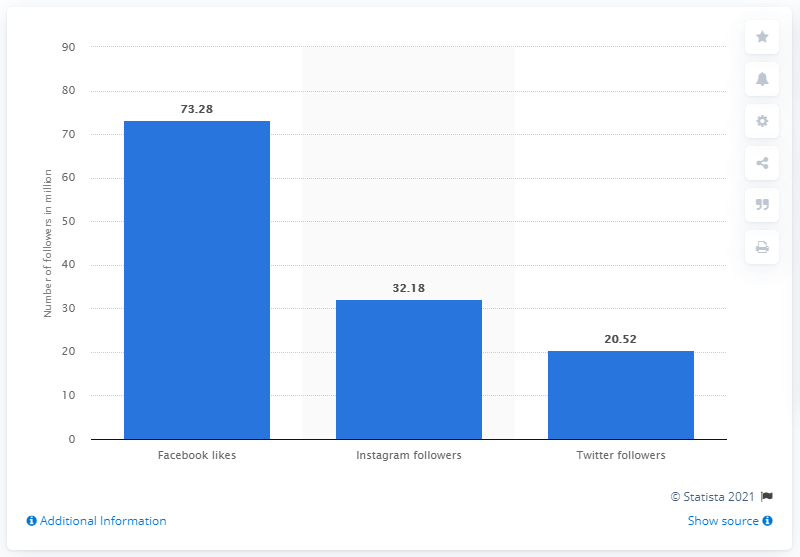Specify some key components in this picture. In November 2019, Manchester United had 73,280 Facebook fans. 